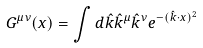<formula> <loc_0><loc_0><loc_500><loc_500>G ^ { \mu \nu } ( { x } ) = \int d \hat { k } { \hat { k } ^ { \mu } \hat { k } ^ { \nu } e ^ { - ( \hat { k } \cdot { x } ) ^ { 2 } } }</formula> 